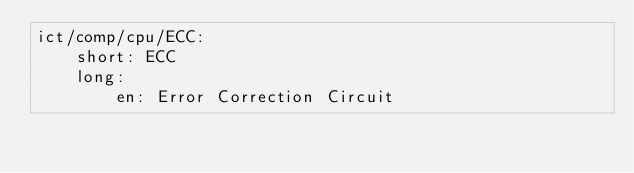Convert code to text. <code><loc_0><loc_0><loc_500><loc_500><_YAML_>ict/comp/cpu/ECC:
    short: ECC
    long:
        en: Error Correction Circuit

</code> 